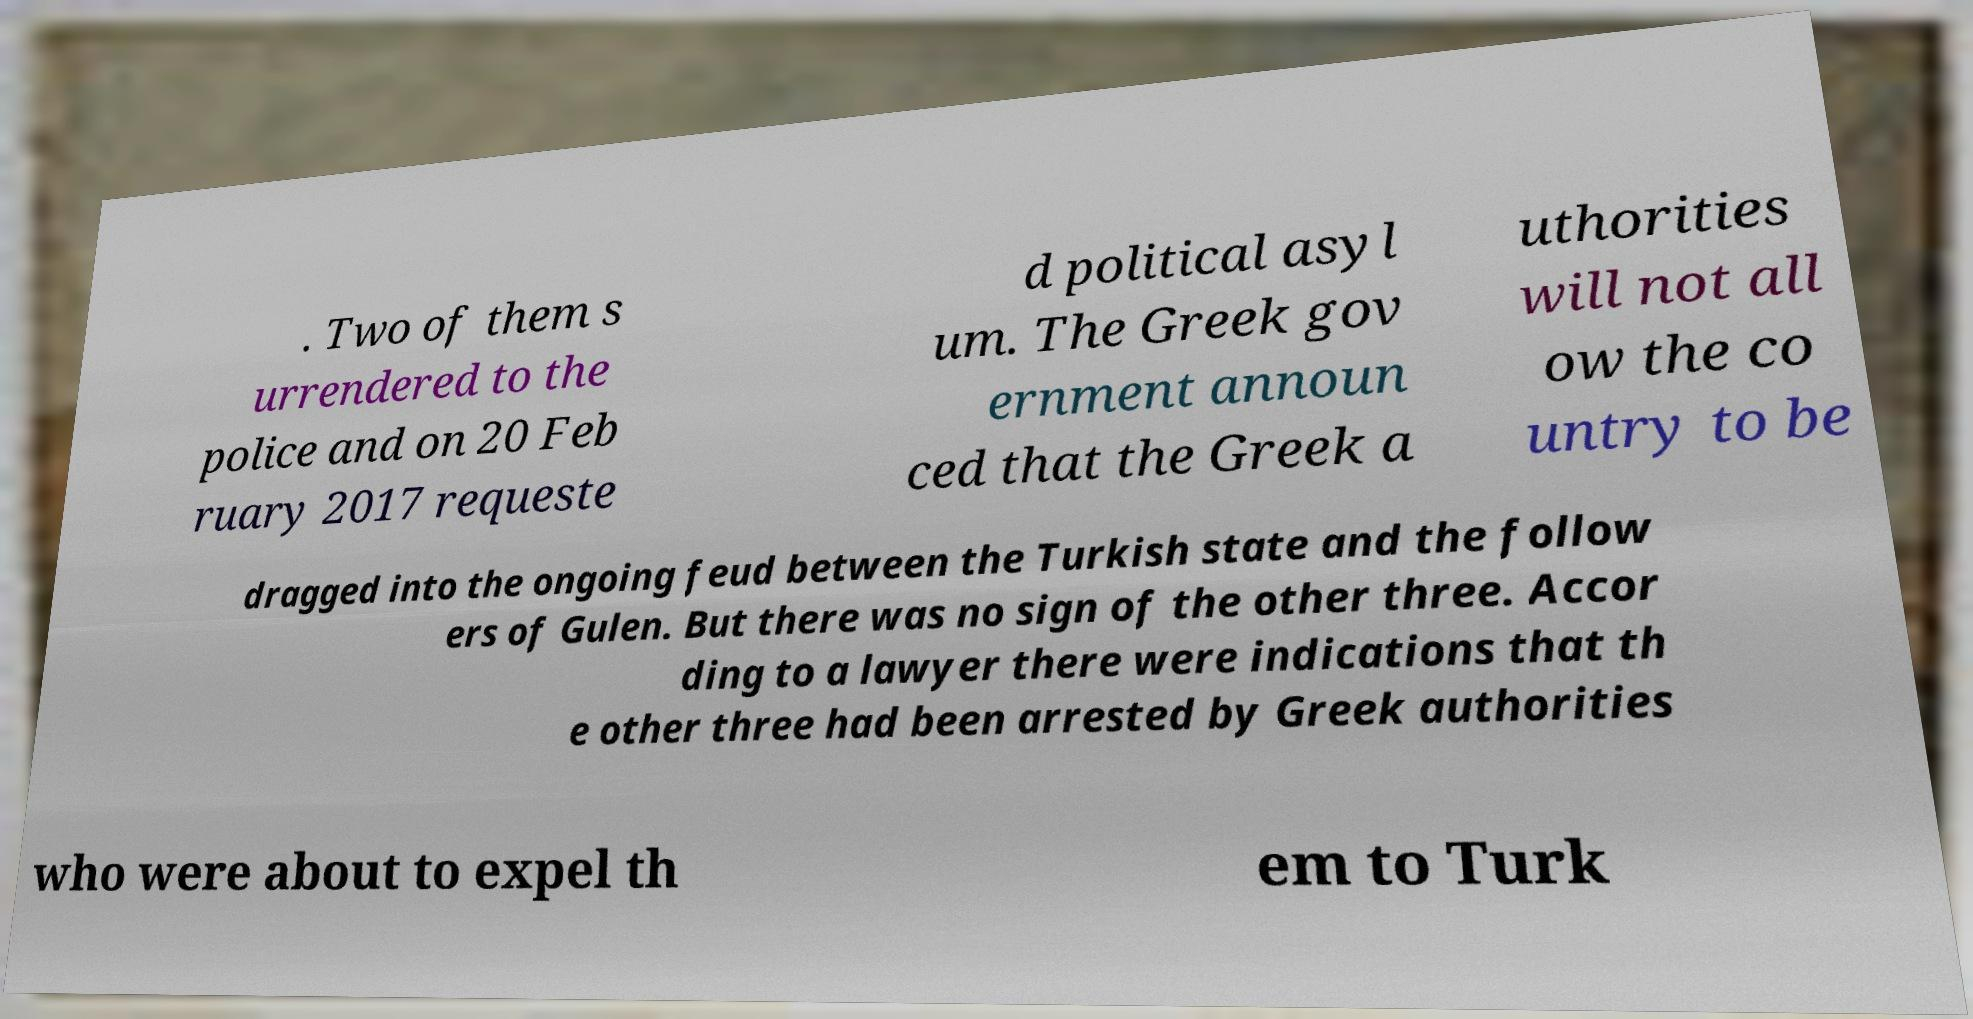Can you accurately transcribe the text from the provided image for me? . Two of them s urrendered to the police and on 20 Feb ruary 2017 requeste d political asyl um. The Greek gov ernment announ ced that the Greek a uthorities will not all ow the co untry to be dragged into the ongoing feud between the Turkish state and the follow ers of Gulen. But there was no sign of the other three. Accor ding to a lawyer there were indications that th e other three had been arrested by Greek authorities who were about to expel th em to Turk 